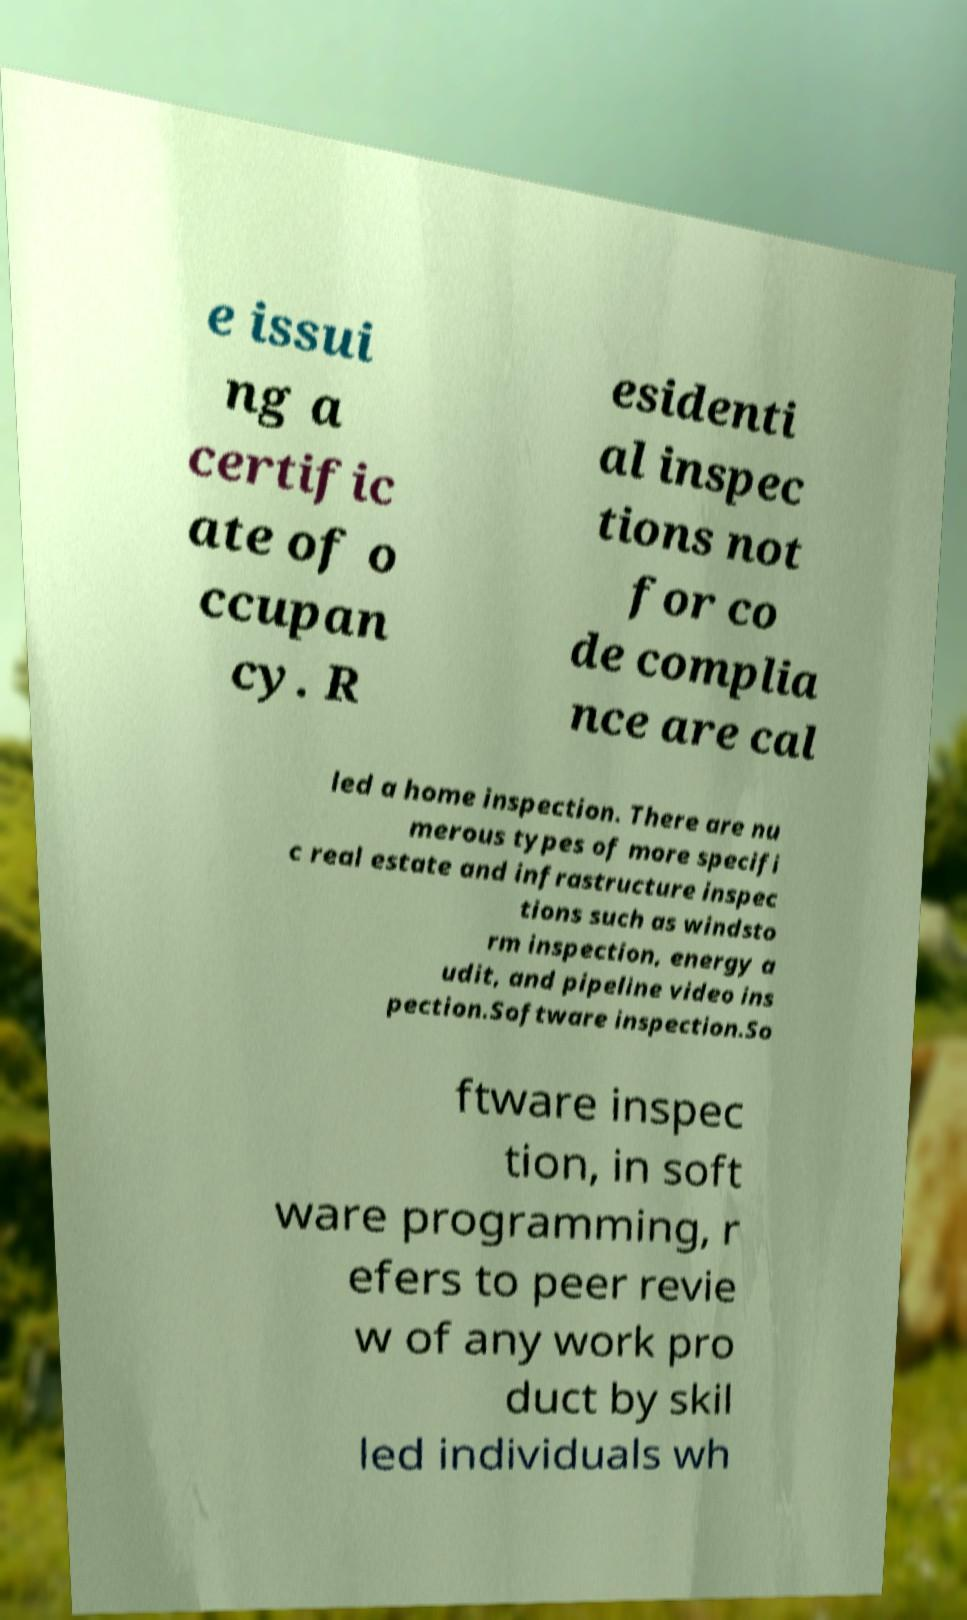Could you extract and type out the text from this image? e issui ng a certific ate of o ccupan cy. R esidenti al inspec tions not for co de complia nce are cal led a home inspection. There are nu merous types of more specifi c real estate and infrastructure inspec tions such as windsto rm inspection, energy a udit, and pipeline video ins pection.Software inspection.So ftware inspec tion, in soft ware programming, r efers to peer revie w of any work pro duct by skil led individuals wh 